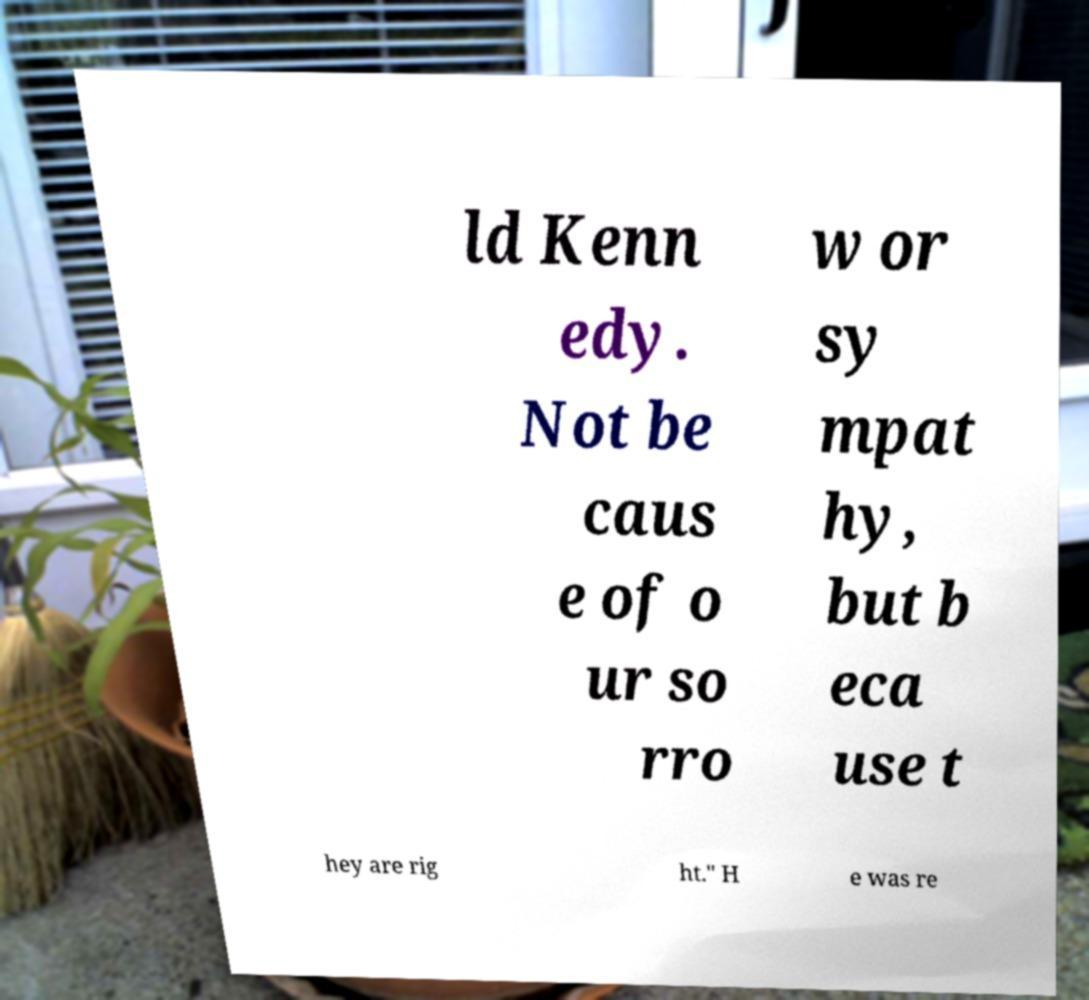There's text embedded in this image that I need extracted. Can you transcribe it verbatim? ld Kenn edy. Not be caus e of o ur so rro w or sy mpat hy, but b eca use t hey are rig ht." H e was re 